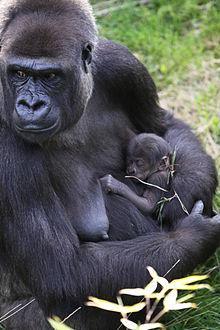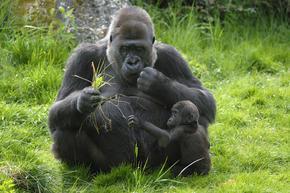The first image is the image on the left, the second image is the image on the right. Given the left and right images, does the statement "An image shows a baby gorilla held in its mother's arms." hold true? Answer yes or no. Yes. The first image is the image on the left, the second image is the image on the right. Given the left and right images, does the statement "A gorilla is holding a baby in one of the images." hold true? Answer yes or no. Yes. 